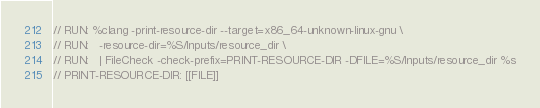<code> <loc_0><loc_0><loc_500><loc_500><_C_>// RUN: %clang -print-resource-dir --target=x86_64-unknown-linux-gnu \
// RUN:   -resource-dir=%S/Inputs/resource_dir \
// RUN:   | FileCheck -check-prefix=PRINT-RESOURCE-DIR -DFILE=%S/Inputs/resource_dir %s
// PRINT-RESOURCE-DIR: [[FILE]]
</code> 